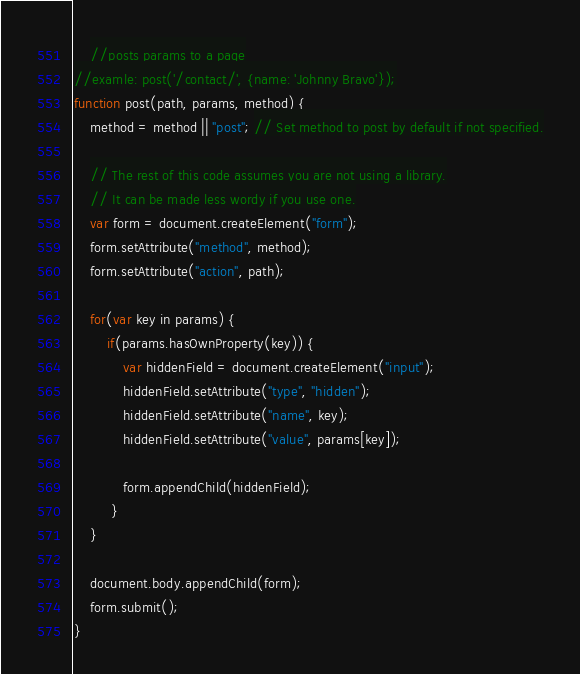Convert code to text. <code><loc_0><loc_0><loc_500><loc_500><_JavaScript_>    //posts params to a page
//examle: post('/contact/', {name: 'Johnny Bravo'});
function post(path, params, method) {
    method = method || "post"; // Set method to post by default if not specified.

    // The rest of this code assumes you are not using a library.
    // It can be made less wordy if you use one.
    var form = document.createElement("form");
    form.setAttribute("method", method);
    form.setAttribute("action", path);

    for(var key in params) {
        if(params.hasOwnProperty(key)) {
            var hiddenField = document.createElement("input");
            hiddenField.setAttribute("type", "hidden");
            hiddenField.setAttribute("name", key);
            hiddenField.setAttribute("value", params[key]);

            form.appendChild(hiddenField);
         }
    }

    document.body.appendChild(form);
    form.submit();
}

</code> 